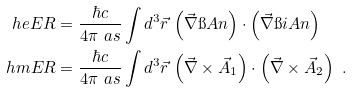Convert formula to latex. <formula><loc_0><loc_0><loc_500><loc_500>\ h e E R & = \frac { \hbar { c } } { 4 \pi \ a s } \int d ^ { 3 } \vec { r } \, \left ( \vec { \nabla } \i A n \right ) \cdot \left ( \vec { \nabla } \i i A n \right ) \\ \ h m E R & = \frac { \hbar { c } } { 4 \pi \ a s } \int d ^ { 3 } \vec { r } \, \left ( \vec { \nabla } \times \vec { A } _ { 1 } \right ) \cdot \left ( \vec { \nabla } \times \vec { A } _ { 2 } \right ) \ .</formula> 